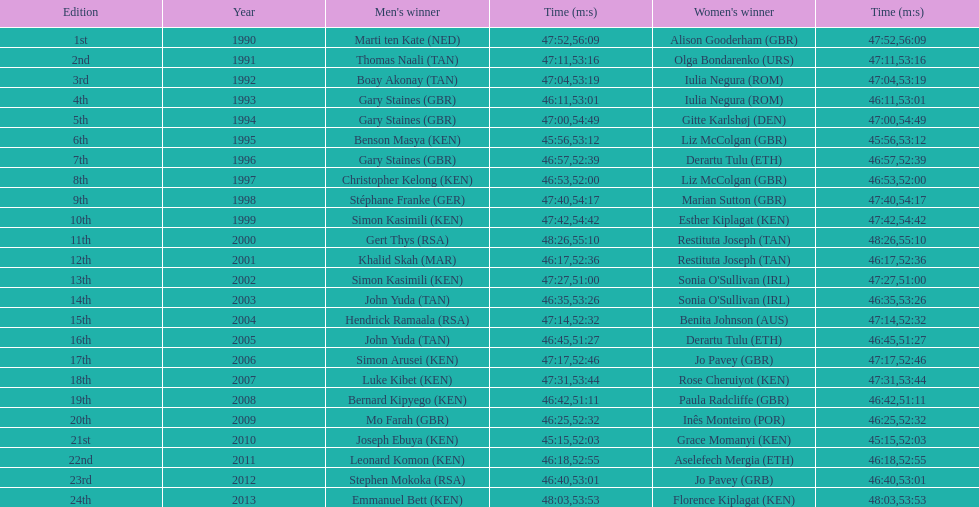What is the difference in finishing times for the men's and women's bupa great south run finish for 2013? 5:50. 